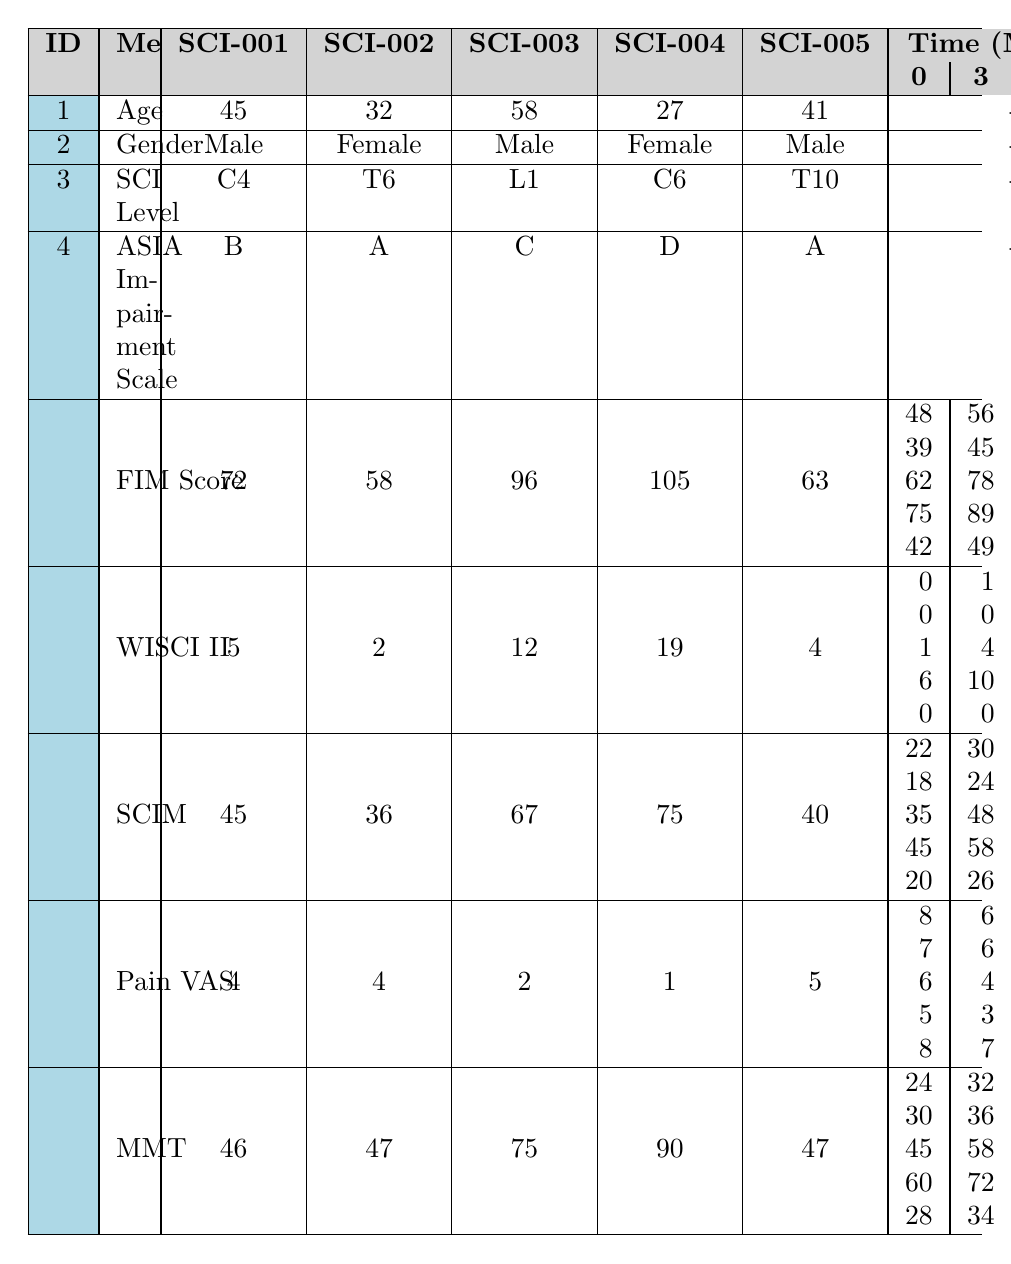What is the initial FIM score for patient SCI-003? The FIM score at the initial measurement for patient SCI-003 is listed in the table as 62.
Answer: 62 What is the WISCI II score for SCI-001 at 6 months? The WISCI II score for patient SCI-001 at 6 months is shown in the table as 3.
Answer: 3 Did the pain level (VAS) improve for all patients by the 12-month mark? By comparing the initial VAS scores to the VAS scores at 12 months, patient SCI-003 and SCI-004 both improved, but patient SCI-002 maintained the same score. Therefore, not all patients improved.
Answer: No What was the percentage increase in the FIM score for SCI-004 from the initial score to the score at 12 months? The initial FIM score for SCI-004 is 75 and at 12 months it is 105. The increase is 105 - 75 = 30. The percentage increase is (30 / 75) * 100 = 40%.
Answer: 40% What is the highest initial SCIM score among all patients? By reviewing the initial SCIM scores in the table, the maximum score is identified as 45 from patient SCI-004.
Answer: 45 Which patient experienced the largest reduction in pain (VAS) from initial to 12 months? Looking at the initial and 12-month VAS scores, patient SCI-004 had a score drop from 5 to 1, a decrease of 4 points, which is the largest among all.
Answer: SCI-004 What is the average initial age of the patients? The ages of the patients are 45, 32, 58, 27, and 41. The sum is 203, and dividing by 5 gives an average age of 40.6.
Answer: 40.6 How did the FIM score change from 3 months to 6 months for patient SCI-005? For patient SCI-005, the FIM score at 3 months was 49 and at 6 months it was 57. The change is 57 - 49 = 8.
Answer: 8 Which SCI level had the lowest average initial FIM score? The initial FIM scores for the levels are: C4 (48), T6 (39), L1 (62), C6 (75), T10 (42). The lowest is for T6, with a score of 39.
Answer: T6 Determine the total improvement (sum of changes) in MMT scores for all patients from 0 to 12 months. The MMT scores for all patients at 0 and 12 months are summed: (46 - 24) + (47 - 30) + (75 - 45) + (90 - 60) + (47 - 28) = 22 + 17 + 30 + 30 + 19 = 118.
Answer: 118 What is the trend of the Pain VAS score over the 12 months for SCI-002? From the table, the VAS scores for SCI-002 are 7, 6, 5, and 4 over the months, indicating a consistent downward trend in pain levels.
Answer: Downward trend 